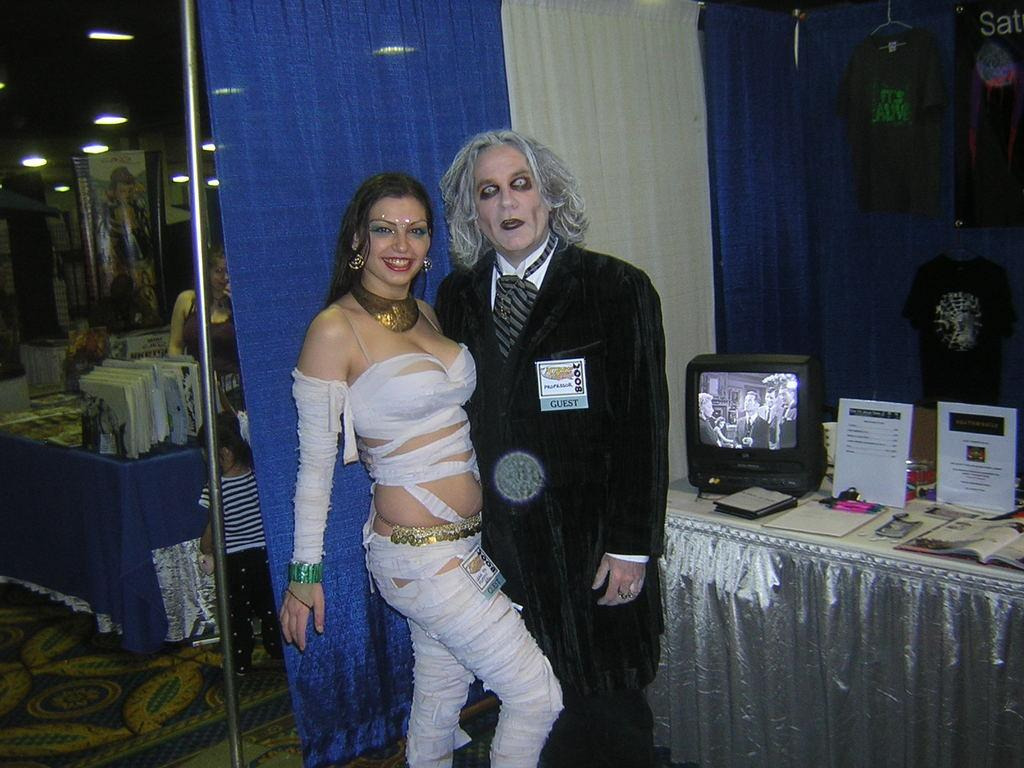How many people are present in the image? There are two people standing in the image. What can be seen on the right side of the image? There is a black color television on the right side of the image. What type of window treatment is visible in the image? There is a blue color curtain in the image. What is the number of times the people in the image jump up and down? There is no indication in the image that the people are jumping up and down, so it cannot be determined from the picture. 